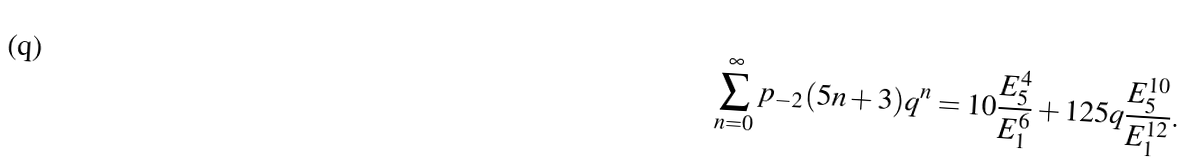Convert formula to latex. <formula><loc_0><loc_0><loc_500><loc_500>\sum _ { n = 0 } ^ { \infty } p _ { - 2 } ( 5 n + 3 ) q ^ { n } & = 1 0 \frac { E _ { 5 } ^ { 4 } } { E _ { 1 } ^ { 6 } } + 1 2 5 q \frac { E _ { 5 } ^ { 1 0 } } { E _ { 1 } ^ { 1 2 } } .</formula> 